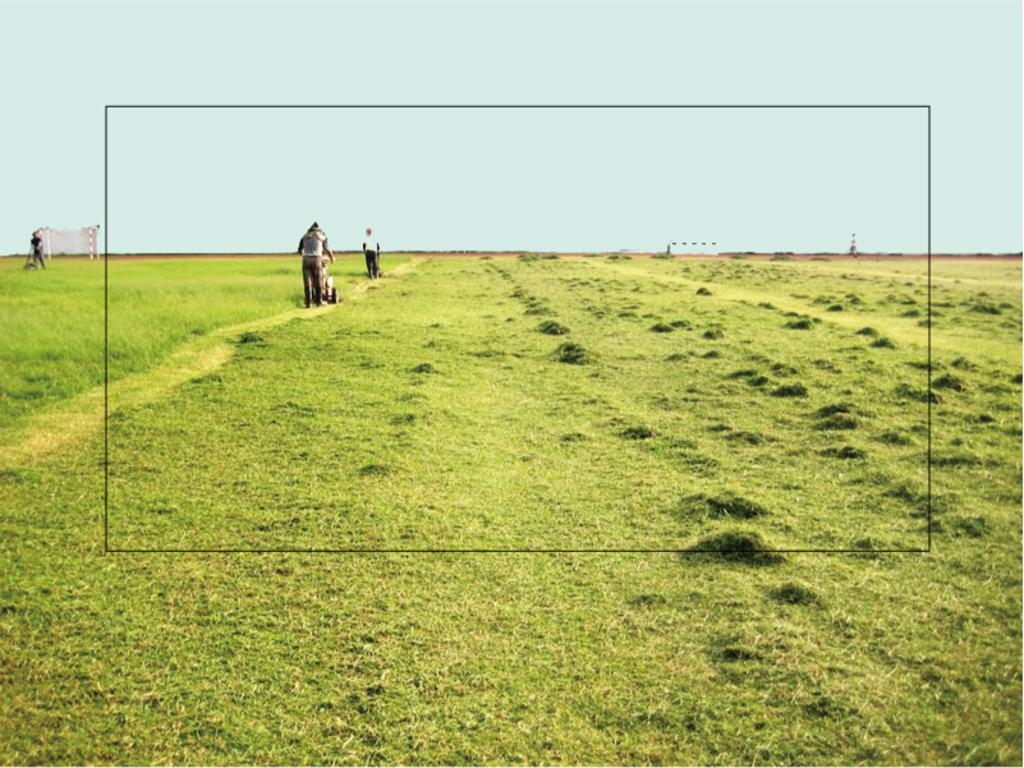How many people are in the image? There are three persons in the image. What are the persons doing in the image? The persons are using grass cutters. Where does the scene take place? The scene takes place in a field. What other objects can be seen in the image? There is a goal post and a small pole in the image. What is visible in the background of the image? The sky is visible in the image. Can you see a stranger riding a horse in the cave in the image? There is no cave, stranger, or horse present in the image. 